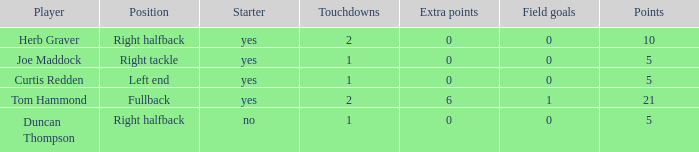Name the most extra points for right tackle 0.0. Can you give me this table as a dict? {'header': ['Player', 'Position', 'Starter', 'Touchdowns', 'Extra points', 'Field goals', 'Points'], 'rows': [['Herb Graver', 'Right halfback', 'yes', '2', '0', '0', '10'], ['Joe Maddock', 'Right tackle', 'yes', '1', '0', '0', '5'], ['Curtis Redden', 'Left end', 'yes', '1', '0', '0', '5'], ['Tom Hammond', 'Fullback', 'yes', '2', '6', '1', '21'], ['Duncan Thompson', 'Right halfback', 'no', '1', '0', '0', '5']]} 